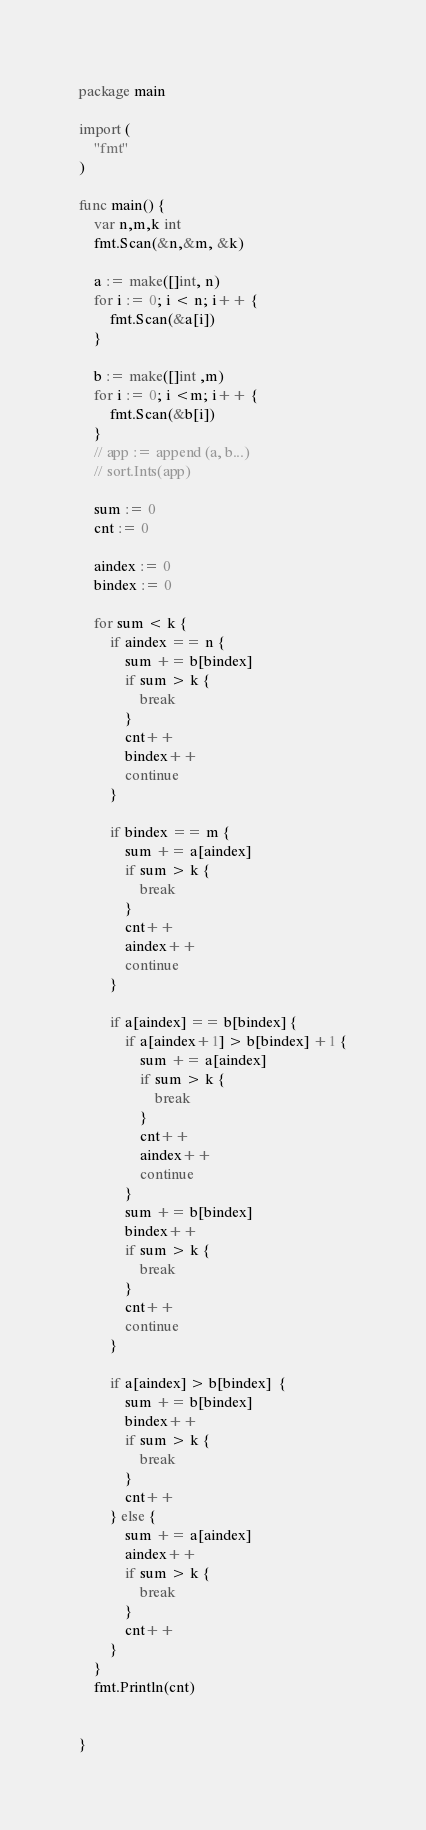Convert code to text. <code><loc_0><loc_0><loc_500><loc_500><_Go_>package main

import (
	"fmt"
)

func main() {
	var n,m,k int
	fmt.Scan(&n,&m, &k)

	a := make([]int, n)
	for i := 0; i < n; i++ {
		fmt.Scan(&a[i])
	}

	b := make([]int ,m)
	for i := 0; i <m; i++ {
		fmt.Scan(&b[i])
	}
	// app := append (a, b...)
	// sort.Ints(app)

	sum := 0
	cnt := 0

	aindex := 0
	bindex := 0

	for sum < k {
		if aindex == n {
			sum += b[bindex]
			if sum > k {
				break
			}
			cnt++
			bindex++
			continue
		}

		if bindex == m {
			sum += a[aindex]
			if sum > k {
				break
			}
			cnt++
			aindex++
			continue
		}

		if a[aindex] == b[bindex] {
			if a[aindex+1] > b[bindex] +1 {
				sum += a[aindex]
				if sum > k {
					break
				}
				cnt++
				aindex++
				continue
			}
			sum += b[bindex]
			bindex++
			if sum > k {
				break
			}
			cnt++
			continue
		}

		if a[aindex] > b[bindex]  {
			sum += b[bindex]
			bindex++
			if sum > k {
				break
			}
			cnt++
		} else {
			sum += a[aindex]
			aindex++
			if sum > k {
				break
			}
			cnt++
		}
	}
	fmt.Println(cnt)


}

</code> 